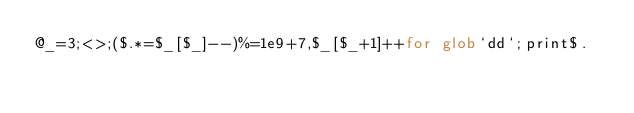<code> <loc_0><loc_0><loc_500><loc_500><_Perl_>@_=3;<>;($.*=$_[$_]--)%=1e9+7,$_[$_+1]++for glob`dd`;print$.</code> 